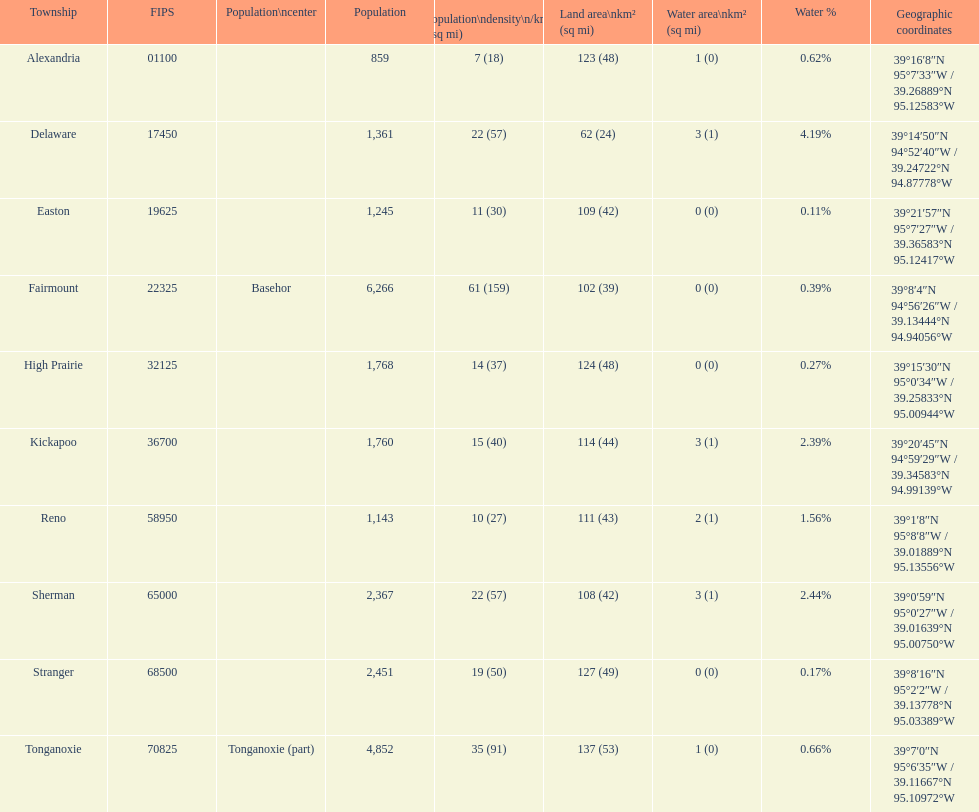Which township covers the most extensive land area? Tonganoxie. 